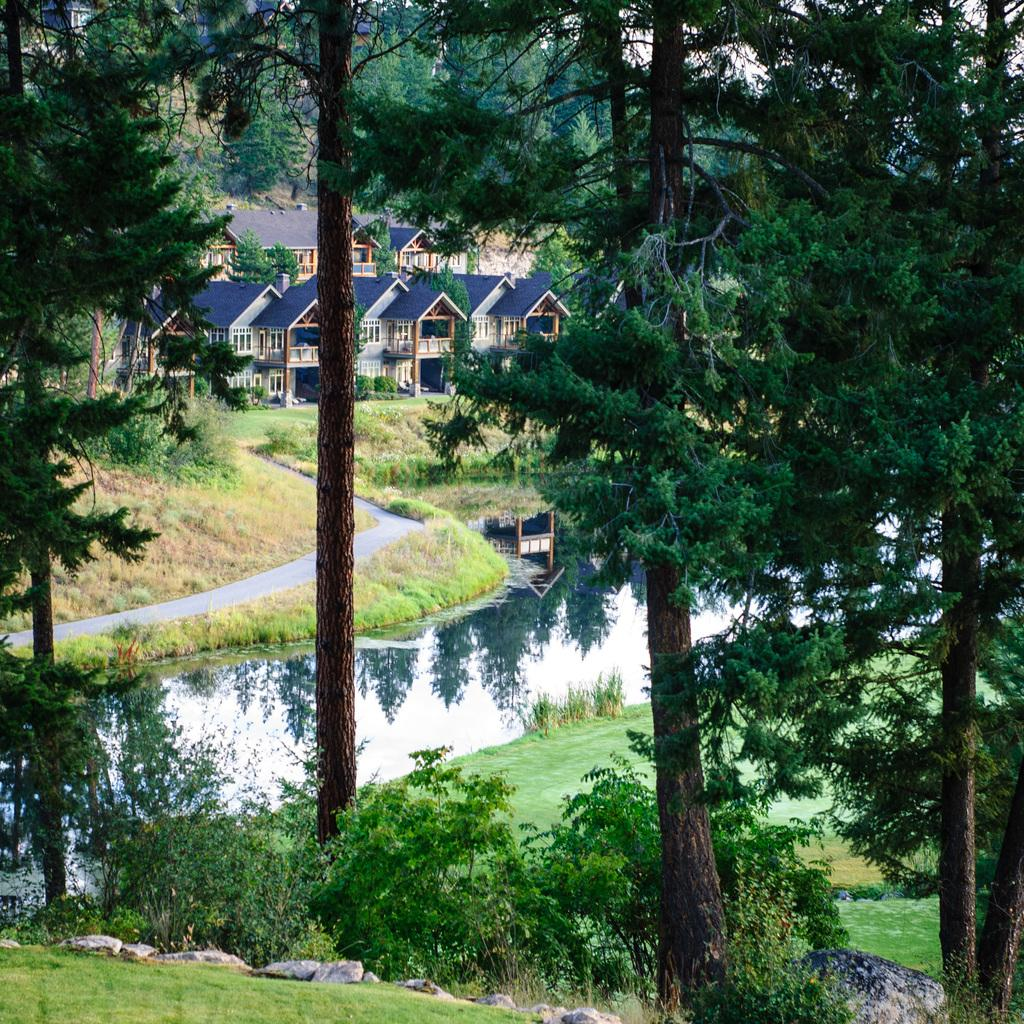What type of vegetation is present in the image? There are trees in the image. What is the ground surface like around the trees? The trees are around a grass surface. What body of water is visible in the image? There is a lake in the image. What surrounds the lake in the image? The lake is surrounded by grass. What structures can be seen behind the lake? There are houses behind the lake. What type of drug is being compared to the lake in the image? There is no drug present in the image, nor is there any comparison being made between the lake and a drug. 